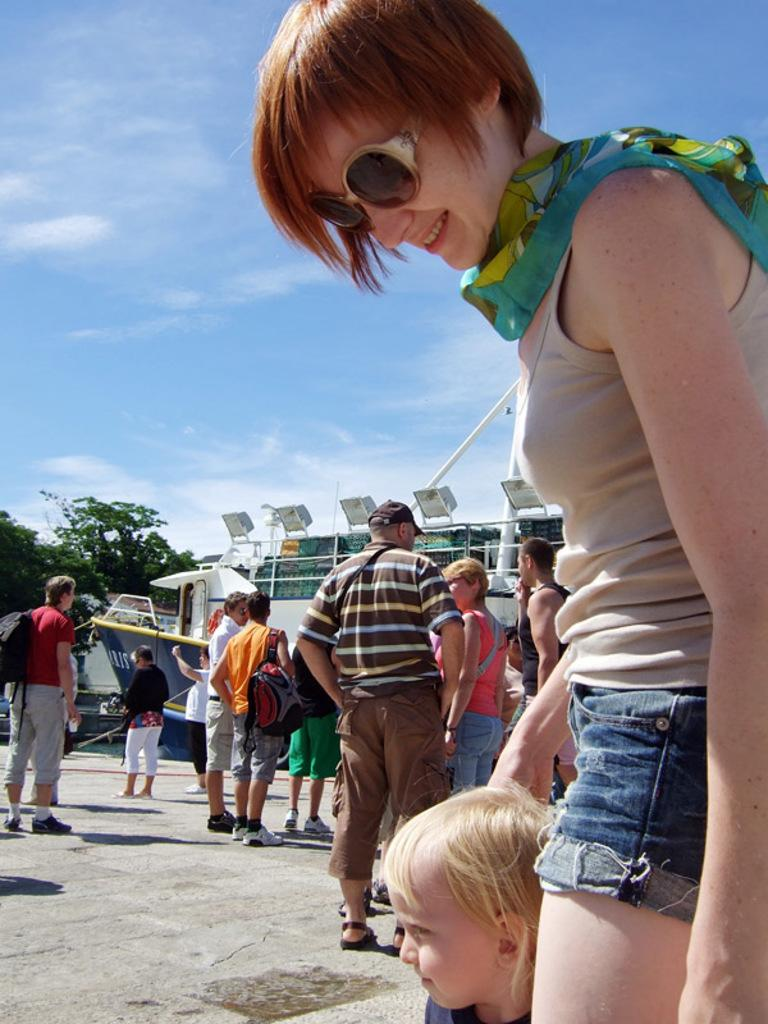What is the main subject in the foreground of the image? There is a crowd in the foreground of the image. Where is the crowd located? The crowd is on the road. What can be seen in the background of the image? There are buildings, lights, trees, vehicles, and the sky visible in the background of the image. Can you describe the time of day when the image was likely taken? The image was likely taken during the day, as the sky is visible and there are no visible light sources that would indicate nighttime. What is the purpose of the man standing on the step in the image? There is no man standing on a step in the image; the image only features a crowd on the road and various elements in the background. 